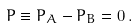<formula> <loc_0><loc_0><loc_500><loc_500>P \equiv P _ { A } - P _ { B } = 0 \, .</formula> 